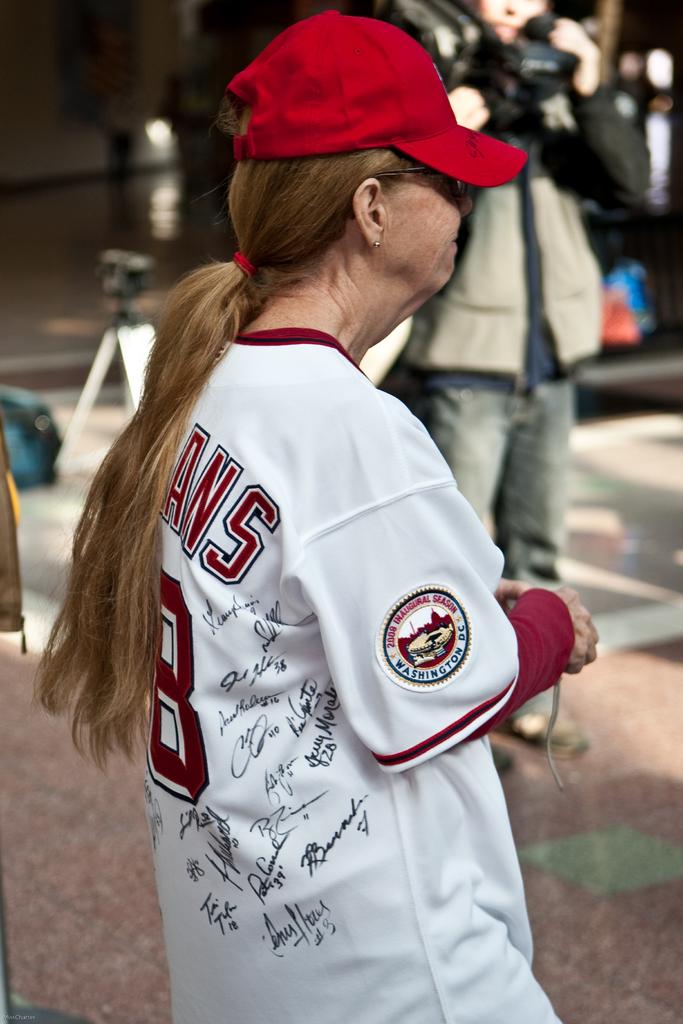In what state is her school?
Your answer should be compact. Washington d.c. What year is written on her arm badge?
Keep it short and to the point. 2008. 